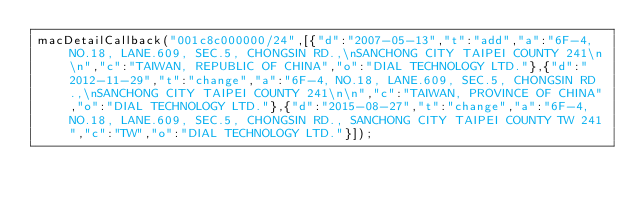<code> <loc_0><loc_0><loc_500><loc_500><_JavaScript_>macDetailCallback("001c8c000000/24",[{"d":"2007-05-13","t":"add","a":"6F-4, NO.18, LANE.609, SEC.5, CHONGSIN RD.,\nSANCHONG CITY TAIPEI COUNTY 241\n\n","c":"TAIWAN, REPUBLIC OF CHINA","o":"DIAL TECHNOLOGY LTD."},{"d":"2012-11-29","t":"change","a":"6F-4, NO.18, LANE.609, SEC.5, CHONGSIN RD.,\nSANCHONG CITY TAIPEI COUNTY 241\n\n","c":"TAIWAN, PROVINCE OF CHINA","o":"DIAL TECHNOLOGY LTD."},{"d":"2015-08-27","t":"change","a":"6F-4, NO.18, LANE.609, SEC.5, CHONGSIN RD., SANCHONG CITY TAIPEI COUNTY TW 241","c":"TW","o":"DIAL TECHNOLOGY LTD."}]);
</code> 